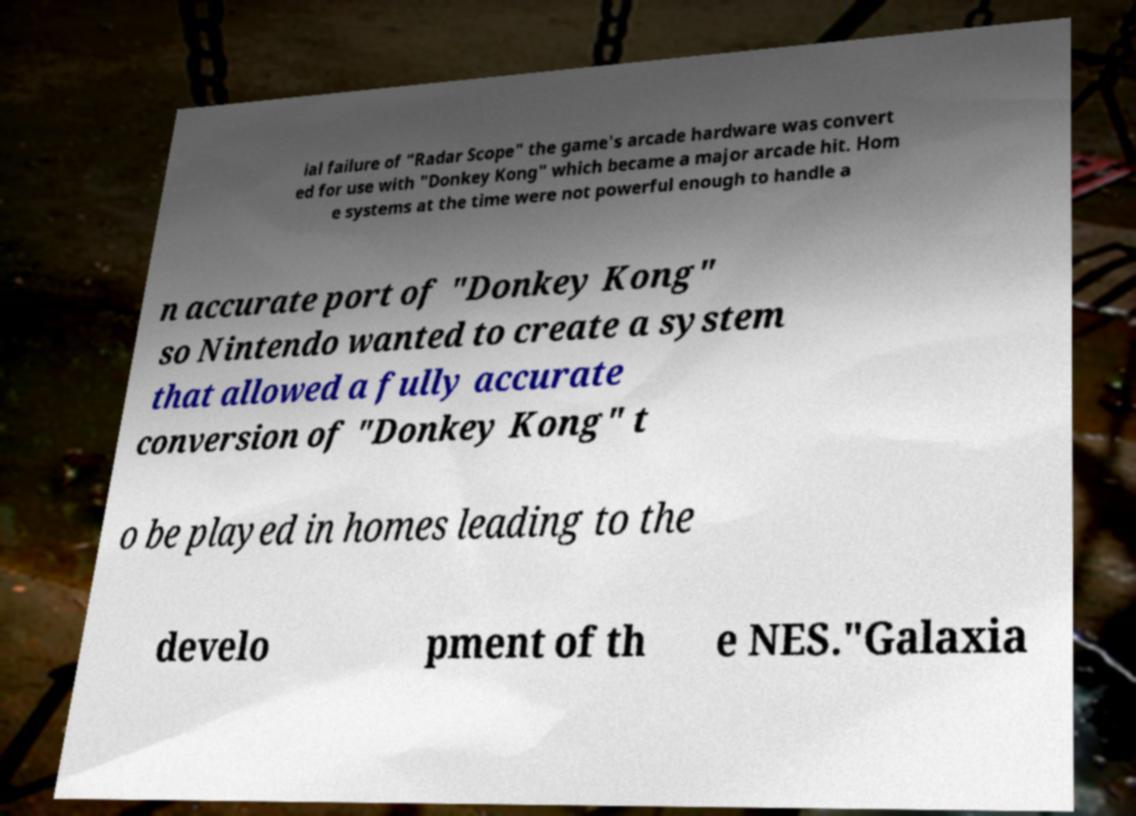For documentation purposes, I need the text within this image transcribed. Could you provide that? ial failure of "Radar Scope" the game's arcade hardware was convert ed for use with "Donkey Kong" which became a major arcade hit. Hom e systems at the time were not powerful enough to handle a n accurate port of "Donkey Kong" so Nintendo wanted to create a system that allowed a fully accurate conversion of "Donkey Kong" t o be played in homes leading to the develo pment of th e NES."Galaxia 